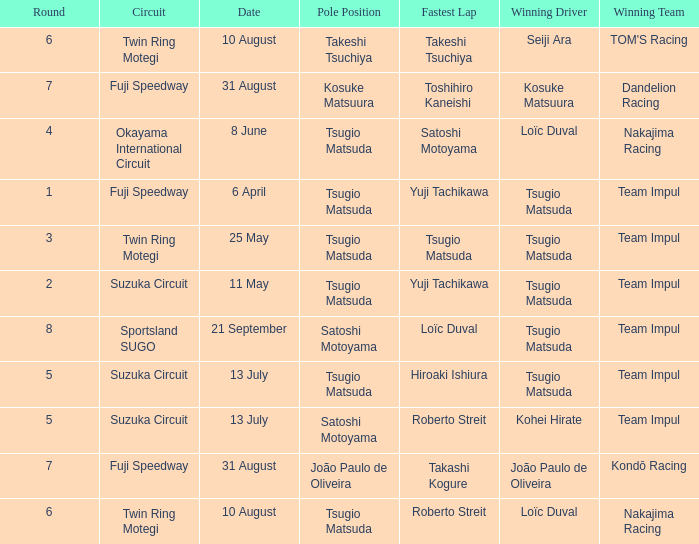On what date does Yuji Tachikawa have the fastest lap in round 1? 6 April. 